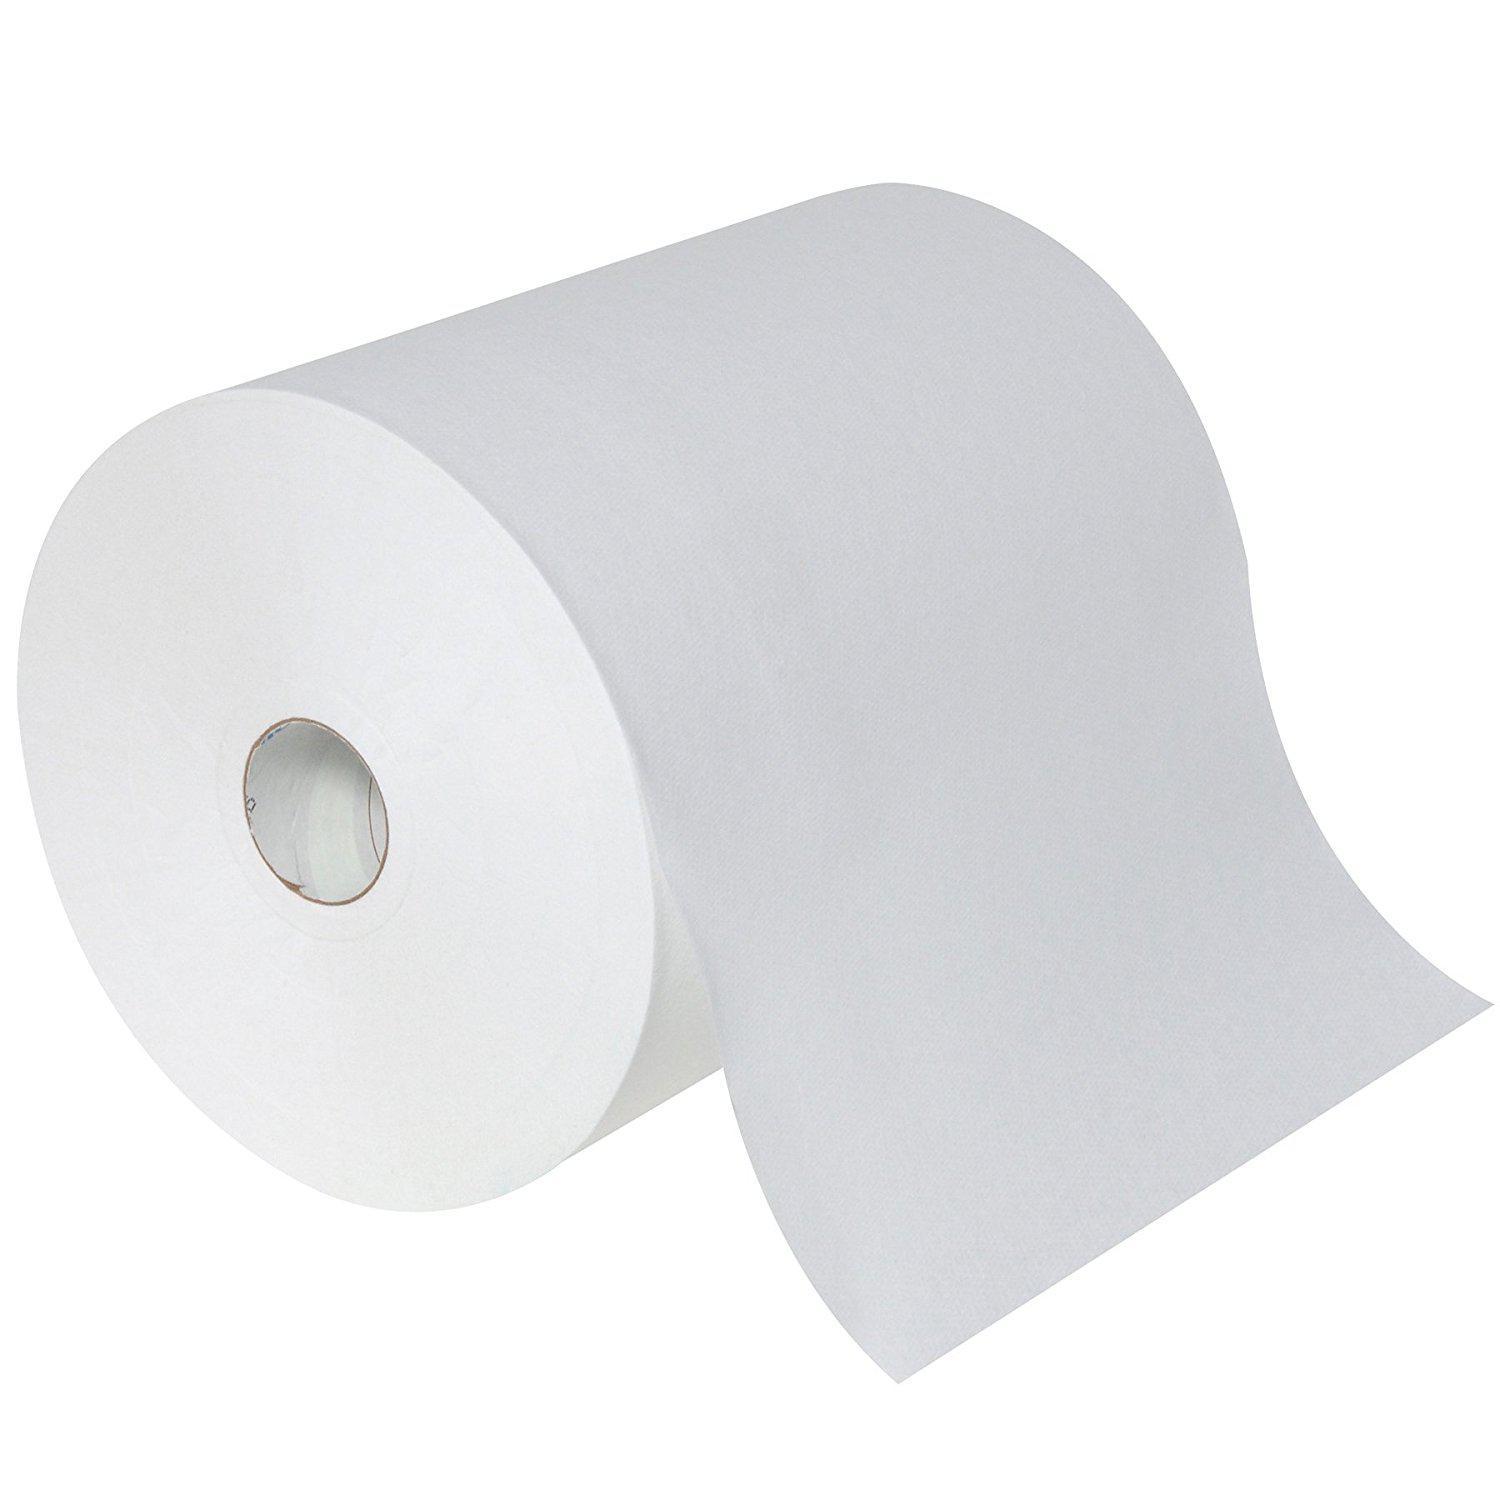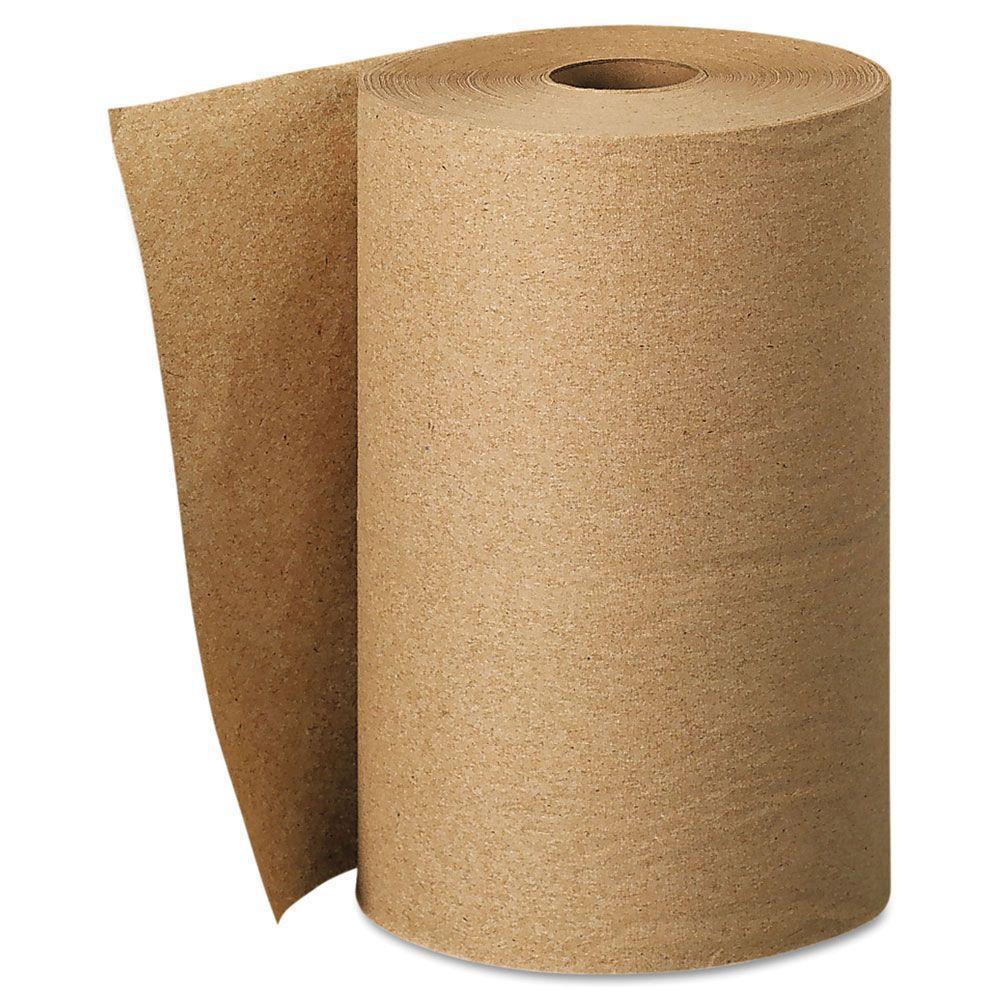The first image is the image on the left, the second image is the image on the right. Assess this claim about the two images: "The left and right images contain the same number of rolls.". Correct or not? Answer yes or no. Yes. 